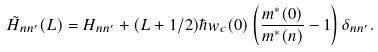<formula> <loc_0><loc_0><loc_500><loc_500>\tilde { H } _ { n n ^ { \prime } } ( L ) = H _ { n n ^ { \prime } } + ( L + 1 / 2 ) \hbar { w } _ { c } ( 0 ) \left ( \frac { m ^ { * } ( 0 ) } { m ^ { * } ( n ) } - 1 \right ) \delta _ { n n ^ { \prime } } .</formula> 